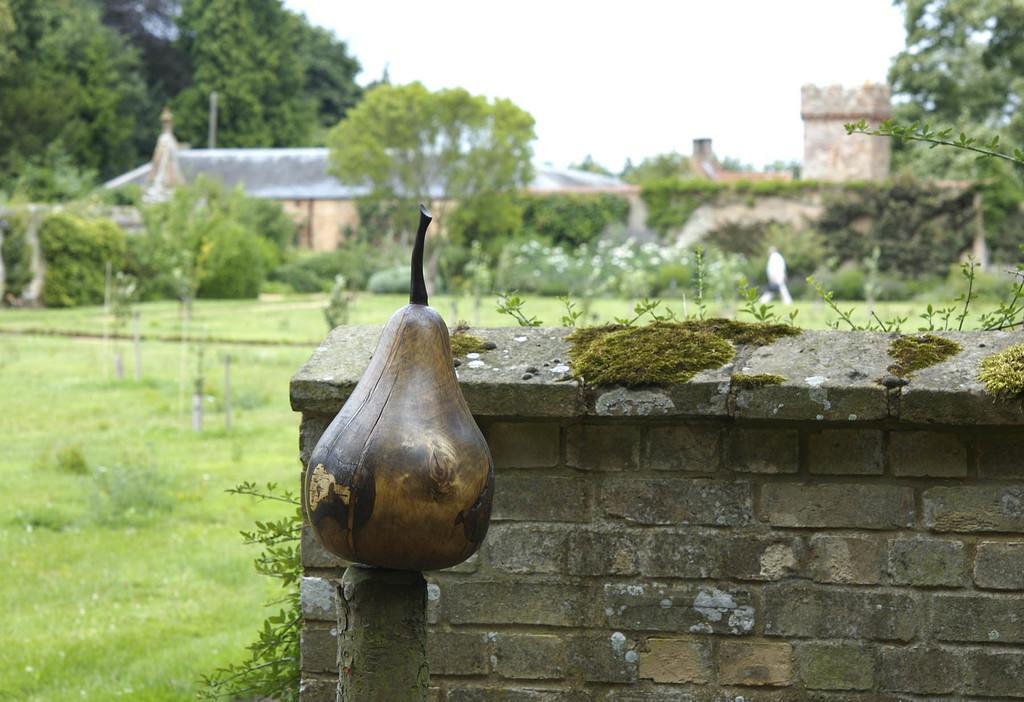Describe this image in one or two sentences. In this picture, it seems like a fruit on a bamboo and a small wall in the foreground area of the image, there are plants, grassland, houses and the sky in the background. 